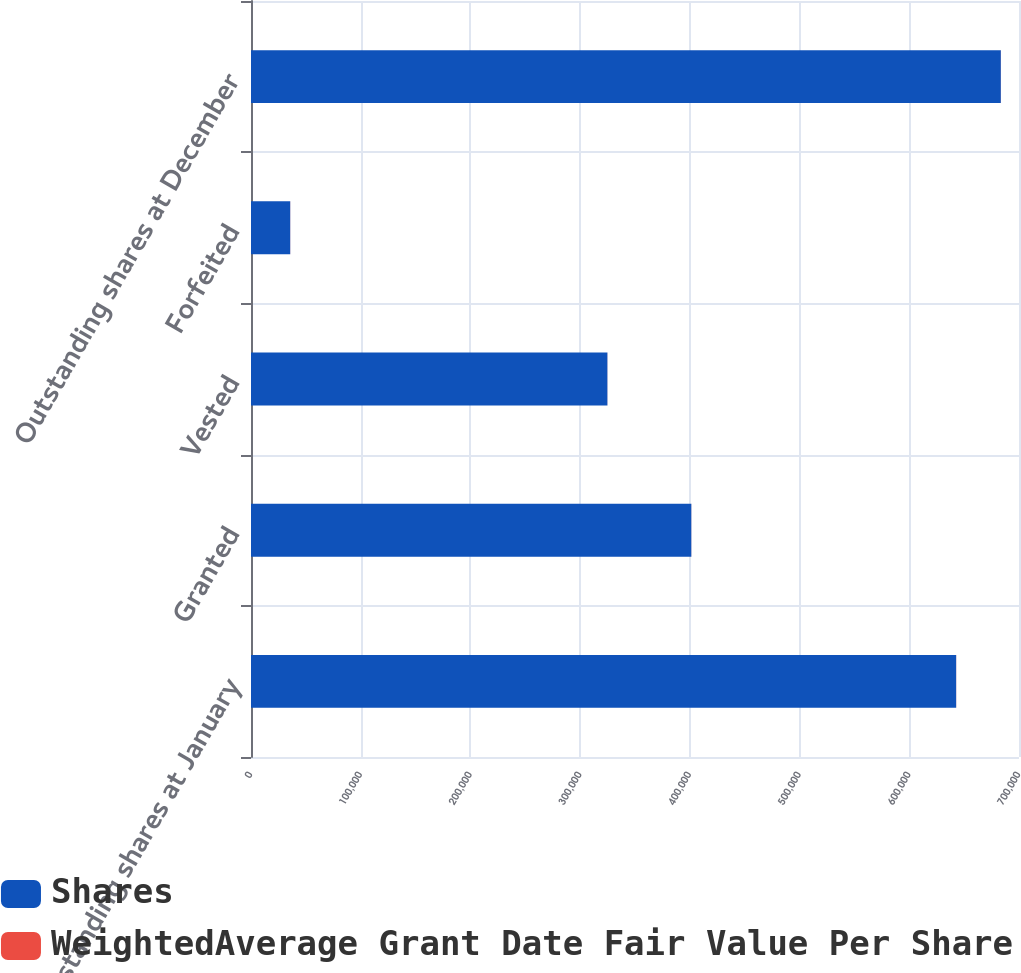Convert chart to OTSL. <chart><loc_0><loc_0><loc_500><loc_500><stacked_bar_chart><ecel><fcel>Outstanding shares at January<fcel>Granted<fcel>Vested<fcel>Forfeited<fcel>Outstanding shares at December<nl><fcel>Shares<fcel>642729<fcel>401358<fcel>324862<fcel>35751<fcel>683474<nl><fcel>WeightedAverage Grant Date Fair Value Per Share<fcel>75.88<fcel>70.89<fcel>71.83<fcel>77.38<fcel>74.8<nl></chart> 